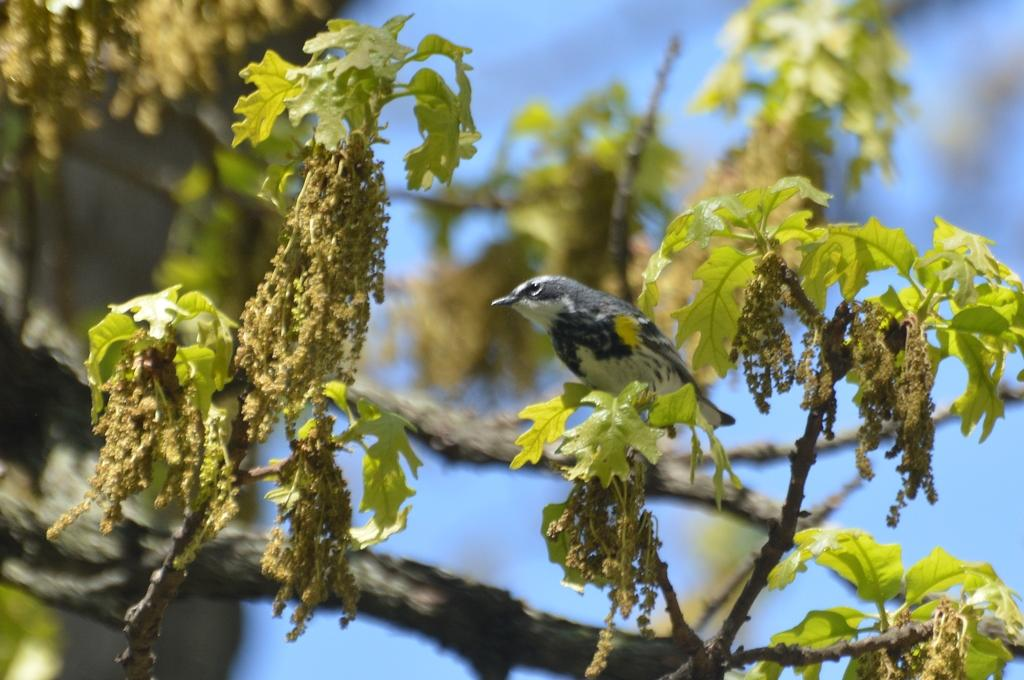What type of natural elements are present in the image? There are branches and leaves in the image. What type of animal can be seen in the image? There is a bird in the image. What colors does the bird have? The bird is white and black in color. What color is the background of the image? The background of the image is blue. Is the bird experiencing any trouble while driving in the image? There is no indication of a bird driving in the image, and therefore no trouble related to driving can be observed. 